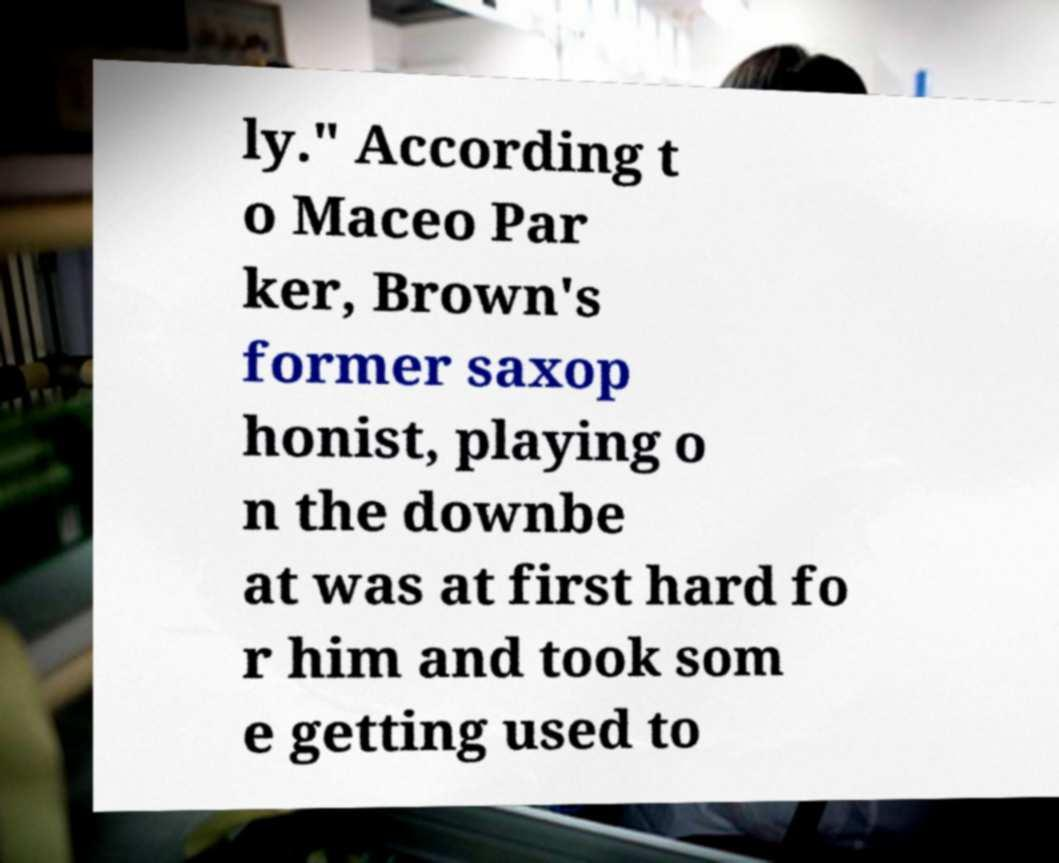There's text embedded in this image that I need extracted. Can you transcribe it verbatim? ly." According t o Maceo Par ker, Brown's former saxop honist, playing o n the downbe at was at first hard fo r him and took som e getting used to 